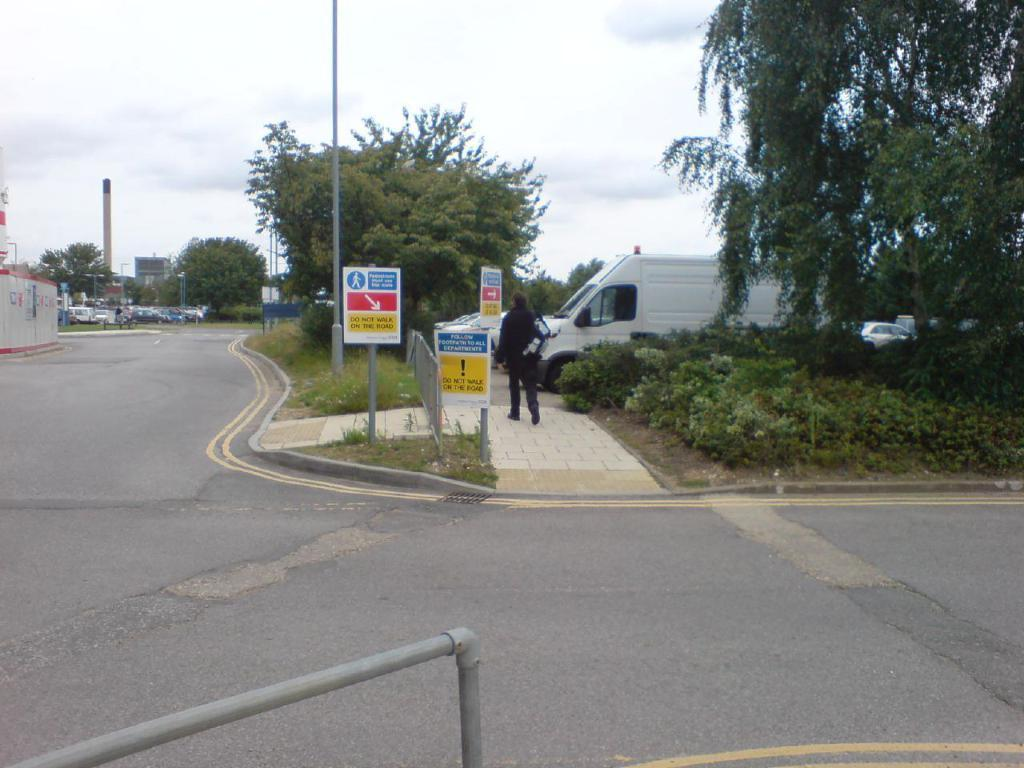<image>
Create a compact narrative representing the image presented. a do not walk sign that is next to a van 